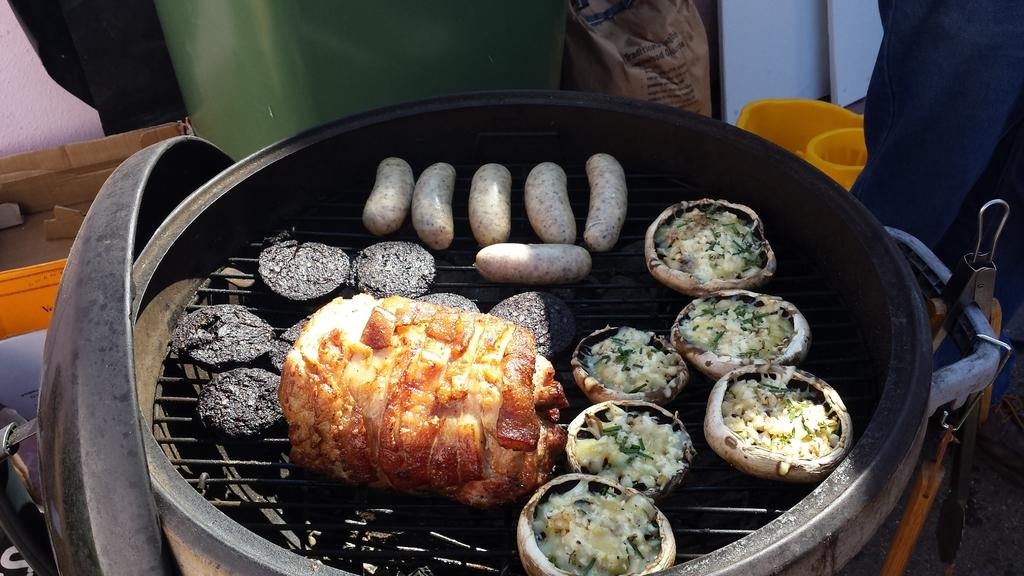What is the main object in the image? There is a machine called grill roster in the image. What is the purpose of the grill roster? The grill roster is used for preparing food. What type of office furniture is present in the image? There is no office furniture present in the image; it features a grill roster for preparing food. How does the grill roster contribute to the wealth of the person using it? The image does not provide any information about the wealth of the person using the grill roster, nor does it suggest that the grill roster contributes to their wealth. 